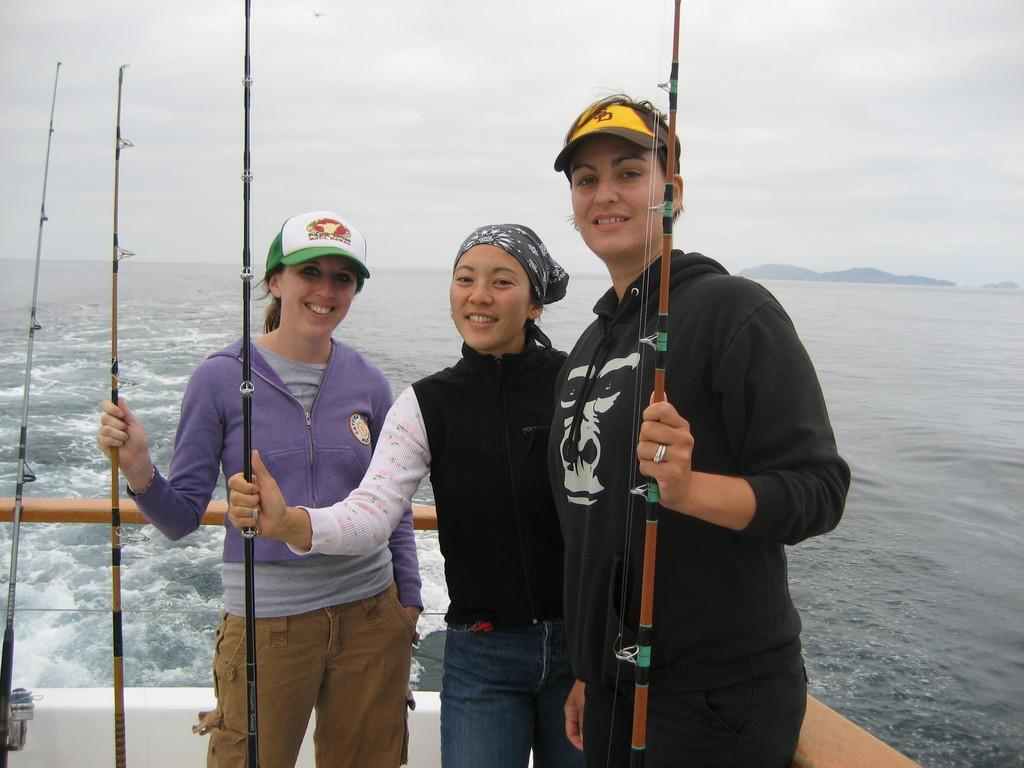How many people are in the image? There are three women in the image. What are the women doing in the image? The women are standing and smiling, and they are holding fishing rods. What can be seen in the background of the image? There is water visible in the background of the image. What is visible at the top of the image? The sky is visible at the top of the image. What type of comfort can be seen in the image? There is no specific type of comfort visible in the image; it features three women holding fishing rods and standing near water. 